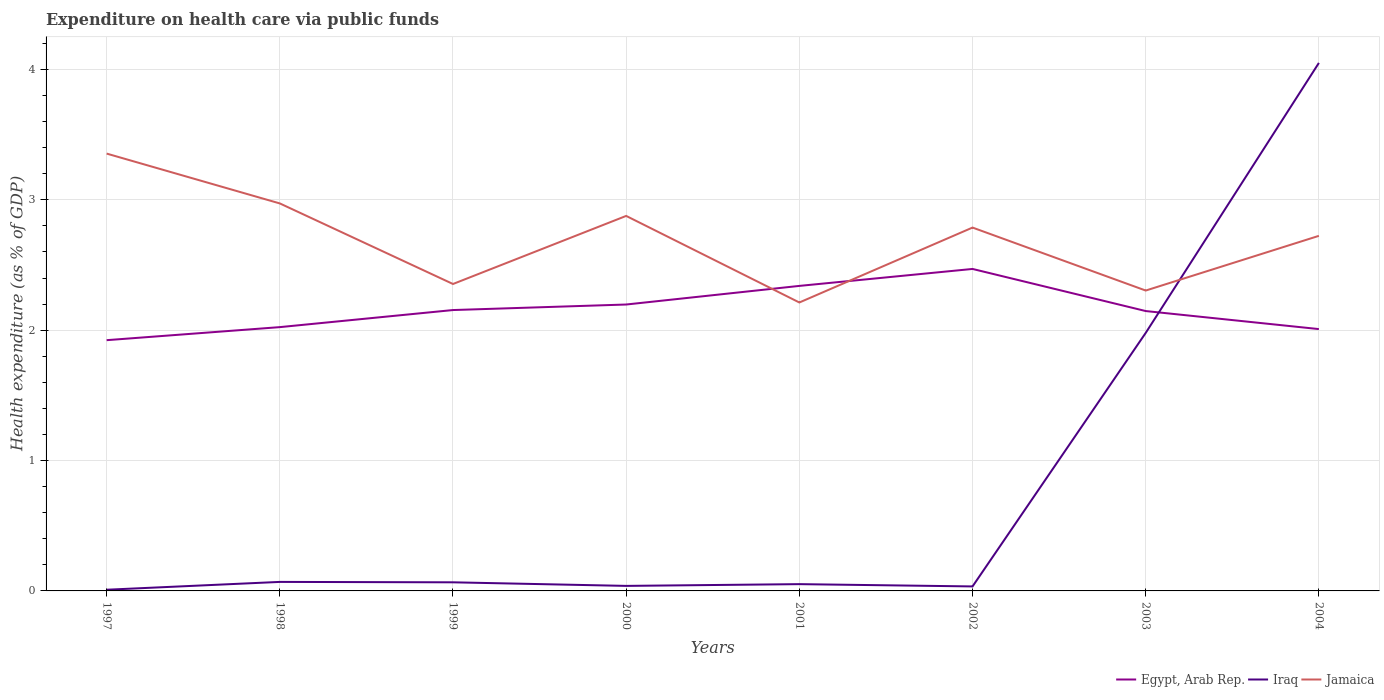How many different coloured lines are there?
Provide a short and direct response. 3. Is the number of lines equal to the number of legend labels?
Your response must be concise. Yes. Across all years, what is the maximum expenditure made on health care in Jamaica?
Your response must be concise. 2.21. In which year was the expenditure made on health care in Jamaica maximum?
Your answer should be compact. 2001. What is the total expenditure made on health care in Egypt, Arab Rep. in the graph?
Make the answer very short. 0.46. What is the difference between the highest and the second highest expenditure made on health care in Jamaica?
Provide a short and direct response. 1.14. What is the difference between the highest and the lowest expenditure made on health care in Iraq?
Offer a terse response. 2. How many years are there in the graph?
Provide a succinct answer. 8. What is the difference between two consecutive major ticks on the Y-axis?
Your answer should be compact. 1. Does the graph contain any zero values?
Make the answer very short. No. Does the graph contain grids?
Ensure brevity in your answer.  Yes. Where does the legend appear in the graph?
Provide a short and direct response. Bottom right. How are the legend labels stacked?
Your answer should be compact. Horizontal. What is the title of the graph?
Your answer should be compact. Expenditure on health care via public funds. What is the label or title of the Y-axis?
Offer a very short reply. Health expenditure (as % of GDP). What is the Health expenditure (as % of GDP) in Egypt, Arab Rep. in 1997?
Provide a succinct answer. 1.92. What is the Health expenditure (as % of GDP) in Iraq in 1997?
Make the answer very short. 0.01. What is the Health expenditure (as % of GDP) in Jamaica in 1997?
Provide a short and direct response. 3.35. What is the Health expenditure (as % of GDP) of Egypt, Arab Rep. in 1998?
Ensure brevity in your answer.  2.02. What is the Health expenditure (as % of GDP) in Iraq in 1998?
Offer a very short reply. 0.07. What is the Health expenditure (as % of GDP) in Jamaica in 1998?
Your response must be concise. 2.97. What is the Health expenditure (as % of GDP) in Egypt, Arab Rep. in 1999?
Provide a succinct answer. 2.15. What is the Health expenditure (as % of GDP) of Iraq in 1999?
Your answer should be compact. 0.07. What is the Health expenditure (as % of GDP) of Jamaica in 1999?
Offer a terse response. 2.35. What is the Health expenditure (as % of GDP) of Egypt, Arab Rep. in 2000?
Make the answer very short. 2.2. What is the Health expenditure (as % of GDP) of Iraq in 2000?
Offer a very short reply. 0.04. What is the Health expenditure (as % of GDP) of Jamaica in 2000?
Your answer should be very brief. 2.88. What is the Health expenditure (as % of GDP) of Egypt, Arab Rep. in 2001?
Offer a terse response. 2.34. What is the Health expenditure (as % of GDP) in Iraq in 2001?
Provide a short and direct response. 0.05. What is the Health expenditure (as % of GDP) in Jamaica in 2001?
Provide a succinct answer. 2.21. What is the Health expenditure (as % of GDP) of Egypt, Arab Rep. in 2002?
Keep it short and to the point. 2.47. What is the Health expenditure (as % of GDP) of Iraq in 2002?
Give a very brief answer. 0.03. What is the Health expenditure (as % of GDP) in Jamaica in 2002?
Ensure brevity in your answer.  2.79. What is the Health expenditure (as % of GDP) in Egypt, Arab Rep. in 2003?
Offer a terse response. 2.15. What is the Health expenditure (as % of GDP) in Iraq in 2003?
Ensure brevity in your answer.  1.98. What is the Health expenditure (as % of GDP) in Jamaica in 2003?
Offer a very short reply. 2.3. What is the Health expenditure (as % of GDP) of Egypt, Arab Rep. in 2004?
Keep it short and to the point. 2.01. What is the Health expenditure (as % of GDP) of Iraq in 2004?
Your answer should be compact. 4.05. What is the Health expenditure (as % of GDP) in Jamaica in 2004?
Your answer should be very brief. 2.72. Across all years, what is the maximum Health expenditure (as % of GDP) of Egypt, Arab Rep.?
Your response must be concise. 2.47. Across all years, what is the maximum Health expenditure (as % of GDP) of Iraq?
Offer a very short reply. 4.05. Across all years, what is the maximum Health expenditure (as % of GDP) in Jamaica?
Ensure brevity in your answer.  3.35. Across all years, what is the minimum Health expenditure (as % of GDP) in Egypt, Arab Rep.?
Provide a short and direct response. 1.92. Across all years, what is the minimum Health expenditure (as % of GDP) in Iraq?
Give a very brief answer. 0.01. Across all years, what is the minimum Health expenditure (as % of GDP) in Jamaica?
Your response must be concise. 2.21. What is the total Health expenditure (as % of GDP) in Egypt, Arab Rep. in the graph?
Make the answer very short. 17.26. What is the total Health expenditure (as % of GDP) of Iraq in the graph?
Make the answer very short. 6.3. What is the total Health expenditure (as % of GDP) of Jamaica in the graph?
Make the answer very short. 21.59. What is the difference between the Health expenditure (as % of GDP) in Egypt, Arab Rep. in 1997 and that in 1998?
Make the answer very short. -0.1. What is the difference between the Health expenditure (as % of GDP) in Iraq in 1997 and that in 1998?
Keep it short and to the point. -0.06. What is the difference between the Health expenditure (as % of GDP) in Jamaica in 1997 and that in 1998?
Offer a very short reply. 0.38. What is the difference between the Health expenditure (as % of GDP) in Egypt, Arab Rep. in 1997 and that in 1999?
Provide a succinct answer. -0.23. What is the difference between the Health expenditure (as % of GDP) in Iraq in 1997 and that in 1999?
Provide a short and direct response. -0.06. What is the difference between the Health expenditure (as % of GDP) in Egypt, Arab Rep. in 1997 and that in 2000?
Provide a succinct answer. -0.27. What is the difference between the Health expenditure (as % of GDP) of Iraq in 1997 and that in 2000?
Make the answer very short. -0.03. What is the difference between the Health expenditure (as % of GDP) in Jamaica in 1997 and that in 2000?
Provide a succinct answer. 0.48. What is the difference between the Health expenditure (as % of GDP) of Egypt, Arab Rep. in 1997 and that in 2001?
Ensure brevity in your answer.  -0.42. What is the difference between the Health expenditure (as % of GDP) of Iraq in 1997 and that in 2001?
Your answer should be very brief. -0.04. What is the difference between the Health expenditure (as % of GDP) of Jamaica in 1997 and that in 2001?
Offer a very short reply. 1.14. What is the difference between the Health expenditure (as % of GDP) in Egypt, Arab Rep. in 1997 and that in 2002?
Your answer should be very brief. -0.55. What is the difference between the Health expenditure (as % of GDP) in Iraq in 1997 and that in 2002?
Ensure brevity in your answer.  -0.03. What is the difference between the Health expenditure (as % of GDP) in Jamaica in 1997 and that in 2002?
Your answer should be compact. 0.57. What is the difference between the Health expenditure (as % of GDP) in Egypt, Arab Rep. in 1997 and that in 2003?
Your answer should be very brief. -0.22. What is the difference between the Health expenditure (as % of GDP) in Iraq in 1997 and that in 2003?
Give a very brief answer. -1.97. What is the difference between the Health expenditure (as % of GDP) of Jamaica in 1997 and that in 2003?
Provide a short and direct response. 1.05. What is the difference between the Health expenditure (as % of GDP) in Egypt, Arab Rep. in 1997 and that in 2004?
Make the answer very short. -0.09. What is the difference between the Health expenditure (as % of GDP) of Iraq in 1997 and that in 2004?
Provide a short and direct response. -4.04. What is the difference between the Health expenditure (as % of GDP) in Jamaica in 1997 and that in 2004?
Ensure brevity in your answer.  0.63. What is the difference between the Health expenditure (as % of GDP) of Egypt, Arab Rep. in 1998 and that in 1999?
Ensure brevity in your answer.  -0.13. What is the difference between the Health expenditure (as % of GDP) of Iraq in 1998 and that in 1999?
Your response must be concise. 0. What is the difference between the Health expenditure (as % of GDP) of Jamaica in 1998 and that in 1999?
Provide a succinct answer. 0.62. What is the difference between the Health expenditure (as % of GDP) of Egypt, Arab Rep. in 1998 and that in 2000?
Keep it short and to the point. -0.17. What is the difference between the Health expenditure (as % of GDP) of Iraq in 1998 and that in 2000?
Offer a terse response. 0.03. What is the difference between the Health expenditure (as % of GDP) of Jamaica in 1998 and that in 2000?
Offer a very short reply. 0.1. What is the difference between the Health expenditure (as % of GDP) in Egypt, Arab Rep. in 1998 and that in 2001?
Your answer should be compact. -0.32. What is the difference between the Health expenditure (as % of GDP) in Iraq in 1998 and that in 2001?
Ensure brevity in your answer.  0.02. What is the difference between the Health expenditure (as % of GDP) in Jamaica in 1998 and that in 2001?
Offer a terse response. 0.76. What is the difference between the Health expenditure (as % of GDP) in Egypt, Arab Rep. in 1998 and that in 2002?
Your response must be concise. -0.45. What is the difference between the Health expenditure (as % of GDP) of Iraq in 1998 and that in 2002?
Your answer should be very brief. 0.03. What is the difference between the Health expenditure (as % of GDP) of Jamaica in 1998 and that in 2002?
Provide a short and direct response. 0.19. What is the difference between the Health expenditure (as % of GDP) of Egypt, Arab Rep. in 1998 and that in 2003?
Offer a very short reply. -0.12. What is the difference between the Health expenditure (as % of GDP) in Iraq in 1998 and that in 2003?
Provide a succinct answer. -1.91. What is the difference between the Health expenditure (as % of GDP) of Jamaica in 1998 and that in 2003?
Provide a short and direct response. 0.67. What is the difference between the Health expenditure (as % of GDP) of Egypt, Arab Rep. in 1998 and that in 2004?
Provide a succinct answer. 0.02. What is the difference between the Health expenditure (as % of GDP) in Iraq in 1998 and that in 2004?
Make the answer very short. -3.98. What is the difference between the Health expenditure (as % of GDP) in Jamaica in 1998 and that in 2004?
Make the answer very short. 0.25. What is the difference between the Health expenditure (as % of GDP) of Egypt, Arab Rep. in 1999 and that in 2000?
Offer a terse response. -0.04. What is the difference between the Health expenditure (as % of GDP) of Iraq in 1999 and that in 2000?
Your response must be concise. 0.03. What is the difference between the Health expenditure (as % of GDP) of Jamaica in 1999 and that in 2000?
Keep it short and to the point. -0.52. What is the difference between the Health expenditure (as % of GDP) in Egypt, Arab Rep. in 1999 and that in 2001?
Provide a short and direct response. -0.19. What is the difference between the Health expenditure (as % of GDP) in Iraq in 1999 and that in 2001?
Your answer should be very brief. 0.01. What is the difference between the Health expenditure (as % of GDP) in Jamaica in 1999 and that in 2001?
Provide a short and direct response. 0.14. What is the difference between the Health expenditure (as % of GDP) in Egypt, Arab Rep. in 1999 and that in 2002?
Provide a short and direct response. -0.32. What is the difference between the Health expenditure (as % of GDP) in Iraq in 1999 and that in 2002?
Your response must be concise. 0.03. What is the difference between the Health expenditure (as % of GDP) of Jamaica in 1999 and that in 2002?
Offer a very short reply. -0.43. What is the difference between the Health expenditure (as % of GDP) of Egypt, Arab Rep. in 1999 and that in 2003?
Ensure brevity in your answer.  0.01. What is the difference between the Health expenditure (as % of GDP) in Iraq in 1999 and that in 2003?
Provide a succinct answer. -1.91. What is the difference between the Health expenditure (as % of GDP) of Jamaica in 1999 and that in 2003?
Make the answer very short. 0.05. What is the difference between the Health expenditure (as % of GDP) of Egypt, Arab Rep. in 1999 and that in 2004?
Your response must be concise. 0.15. What is the difference between the Health expenditure (as % of GDP) of Iraq in 1999 and that in 2004?
Offer a very short reply. -3.98. What is the difference between the Health expenditure (as % of GDP) of Jamaica in 1999 and that in 2004?
Offer a very short reply. -0.37. What is the difference between the Health expenditure (as % of GDP) of Egypt, Arab Rep. in 2000 and that in 2001?
Your answer should be very brief. -0.14. What is the difference between the Health expenditure (as % of GDP) of Iraq in 2000 and that in 2001?
Your answer should be very brief. -0.01. What is the difference between the Health expenditure (as % of GDP) of Jamaica in 2000 and that in 2001?
Your answer should be very brief. 0.66. What is the difference between the Health expenditure (as % of GDP) in Egypt, Arab Rep. in 2000 and that in 2002?
Offer a very short reply. -0.27. What is the difference between the Health expenditure (as % of GDP) of Iraq in 2000 and that in 2002?
Provide a short and direct response. 0. What is the difference between the Health expenditure (as % of GDP) in Jamaica in 2000 and that in 2002?
Your answer should be very brief. 0.09. What is the difference between the Health expenditure (as % of GDP) in Egypt, Arab Rep. in 2000 and that in 2003?
Provide a succinct answer. 0.05. What is the difference between the Health expenditure (as % of GDP) of Iraq in 2000 and that in 2003?
Keep it short and to the point. -1.94. What is the difference between the Health expenditure (as % of GDP) in Jamaica in 2000 and that in 2003?
Make the answer very short. 0.57. What is the difference between the Health expenditure (as % of GDP) of Egypt, Arab Rep. in 2000 and that in 2004?
Your answer should be compact. 0.19. What is the difference between the Health expenditure (as % of GDP) of Iraq in 2000 and that in 2004?
Keep it short and to the point. -4.01. What is the difference between the Health expenditure (as % of GDP) in Jamaica in 2000 and that in 2004?
Provide a short and direct response. 0.15. What is the difference between the Health expenditure (as % of GDP) in Egypt, Arab Rep. in 2001 and that in 2002?
Keep it short and to the point. -0.13. What is the difference between the Health expenditure (as % of GDP) in Iraq in 2001 and that in 2002?
Your answer should be very brief. 0.02. What is the difference between the Health expenditure (as % of GDP) in Jamaica in 2001 and that in 2002?
Make the answer very short. -0.57. What is the difference between the Health expenditure (as % of GDP) in Egypt, Arab Rep. in 2001 and that in 2003?
Give a very brief answer. 0.19. What is the difference between the Health expenditure (as % of GDP) in Iraq in 2001 and that in 2003?
Provide a short and direct response. -1.93. What is the difference between the Health expenditure (as % of GDP) of Jamaica in 2001 and that in 2003?
Give a very brief answer. -0.09. What is the difference between the Health expenditure (as % of GDP) in Egypt, Arab Rep. in 2001 and that in 2004?
Your answer should be compact. 0.33. What is the difference between the Health expenditure (as % of GDP) in Iraq in 2001 and that in 2004?
Provide a short and direct response. -4. What is the difference between the Health expenditure (as % of GDP) in Jamaica in 2001 and that in 2004?
Offer a very short reply. -0.51. What is the difference between the Health expenditure (as % of GDP) in Egypt, Arab Rep. in 2002 and that in 2003?
Keep it short and to the point. 0.32. What is the difference between the Health expenditure (as % of GDP) in Iraq in 2002 and that in 2003?
Your answer should be compact. -1.94. What is the difference between the Health expenditure (as % of GDP) in Jamaica in 2002 and that in 2003?
Make the answer very short. 0.48. What is the difference between the Health expenditure (as % of GDP) in Egypt, Arab Rep. in 2002 and that in 2004?
Your response must be concise. 0.46. What is the difference between the Health expenditure (as % of GDP) in Iraq in 2002 and that in 2004?
Provide a short and direct response. -4.02. What is the difference between the Health expenditure (as % of GDP) in Jamaica in 2002 and that in 2004?
Your answer should be very brief. 0.06. What is the difference between the Health expenditure (as % of GDP) in Egypt, Arab Rep. in 2003 and that in 2004?
Ensure brevity in your answer.  0.14. What is the difference between the Health expenditure (as % of GDP) of Iraq in 2003 and that in 2004?
Provide a succinct answer. -2.07. What is the difference between the Health expenditure (as % of GDP) in Jamaica in 2003 and that in 2004?
Your answer should be very brief. -0.42. What is the difference between the Health expenditure (as % of GDP) of Egypt, Arab Rep. in 1997 and the Health expenditure (as % of GDP) of Iraq in 1998?
Your response must be concise. 1.85. What is the difference between the Health expenditure (as % of GDP) of Egypt, Arab Rep. in 1997 and the Health expenditure (as % of GDP) of Jamaica in 1998?
Offer a very short reply. -1.05. What is the difference between the Health expenditure (as % of GDP) in Iraq in 1997 and the Health expenditure (as % of GDP) in Jamaica in 1998?
Your answer should be very brief. -2.96. What is the difference between the Health expenditure (as % of GDP) in Egypt, Arab Rep. in 1997 and the Health expenditure (as % of GDP) in Iraq in 1999?
Your answer should be very brief. 1.86. What is the difference between the Health expenditure (as % of GDP) in Egypt, Arab Rep. in 1997 and the Health expenditure (as % of GDP) in Jamaica in 1999?
Keep it short and to the point. -0.43. What is the difference between the Health expenditure (as % of GDP) of Iraq in 1997 and the Health expenditure (as % of GDP) of Jamaica in 1999?
Keep it short and to the point. -2.35. What is the difference between the Health expenditure (as % of GDP) in Egypt, Arab Rep. in 1997 and the Health expenditure (as % of GDP) in Iraq in 2000?
Your answer should be compact. 1.89. What is the difference between the Health expenditure (as % of GDP) in Egypt, Arab Rep. in 1997 and the Health expenditure (as % of GDP) in Jamaica in 2000?
Your answer should be compact. -0.95. What is the difference between the Health expenditure (as % of GDP) in Iraq in 1997 and the Health expenditure (as % of GDP) in Jamaica in 2000?
Your answer should be very brief. -2.87. What is the difference between the Health expenditure (as % of GDP) in Egypt, Arab Rep. in 1997 and the Health expenditure (as % of GDP) in Iraq in 2001?
Offer a terse response. 1.87. What is the difference between the Health expenditure (as % of GDP) in Egypt, Arab Rep. in 1997 and the Health expenditure (as % of GDP) in Jamaica in 2001?
Your response must be concise. -0.29. What is the difference between the Health expenditure (as % of GDP) of Iraq in 1997 and the Health expenditure (as % of GDP) of Jamaica in 2001?
Your response must be concise. -2.2. What is the difference between the Health expenditure (as % of GDP) of Egypt, Arab Rep. in 1997 and the Health expenditure (as % of GDP) of Iraq in 2002?
Make the answer very short. 1.89. What is the difference between the Health expenditure (as % of GDP) of Egypt, Arab Rep. in 1997 and the Health expenditure (as % of GDP) of Jamaica in 2002?
Offer a very short reply. -0.86. What is the difference between the Health expenditure (as % of GDP) of Iraq in 1997 and the Health expenditure (as % of GDP) of Jamaica in 2002?
Offer a very short reply. -2.78. What is the difference between the Health expenditure (as % of GDP) of Egypt, Arab Rep. in 1997 and the Health expenditure (as % of GDP) of Iraq in 2003?
Ensure brevity in your answer.  -0.06. What is the difference between the Health expenditure (as % of GDP) in Egypt, Arab Rep. in 1997 and the Health expenditure (as % of GDP) in Jamaica in 2003?
Provide a succinct answer. -0.38. What is the difference between the Health expenditure (as % of GDP) in Iraq in 1997 and the Health expenditure (as % of GDP) in Jamaica in 2003?
Provide a succinct answer. -2.3. What is the difference between the Health expenditure (as % of GDP) of Egypt, Arab Rep. in 1997 and the Health expenditure (as % of GDP) of Iraq in 2004?
Make the answer very short. -2.13. What is the difference between the Health expenditure (as % of GDP) of Egypt, Arab Rep. in 1997 and the Health expenditure (as % of GDP) of Jamaica in 2004?
Keep it short and to the point. -0.8. What is the difference between the Health expenditure (as % of GDP) in Iraq in 1997 and the Health expenditure (as % of GDP) in Jamaica in 2004?
Give a very brief answer. -2.71. What is the difference between the Health expenditure (as % of GDP) of Egypt, Arab Rep. in 1998 and the Health expenditure (as % of GDP) of Iraq in 1999?
Offer a very short reply. 1.96. What is the difference between the Health expenditure (as % of GDP) of Egypt, Arab Rep. in 1998 and the Health expenditure (as % of GDP) of Jamaica in 1999?
Provide a succinct answer. -0.33. What is the difference between the Health expenditure (as % of GDP) of Iraq in 1998 and the Health expenditure (as % of GDP) of Jamaica in 1999?
Offer a very short reply. -2.29. What is the difference between the Health expenditure (as % of GDP) of Egypt, Arab Rep. in 1998 and the Health expenditure (as % of GDP) of Iraq in 2000?
Offer a very short reply. 1.99. What is the difference between the Health expenditure (as % of GDP) in Egypt, Arab Rep. in 1998 and the Health expenditure (as % of GDP) in Jamaica in 2000?
Give a very brief answer. -0.85. What is the difference between the Health expenditure (as % of GDP) of Iraq in 1998 and the Health expenditure (as % of GDP) of Jamaica in 2000?
Your response must be concise. -2.81. What is the difference between the Health expenditure (as % of GDP) of Egypt, Arab Rep. in 1998 and the Health expenditure (as % of GDP) of Iraq in 2001?
Keep it short and to the point. 1.97. What is the difference between the Health expenditure (as % of GDP) of Egypt, Arab Rep. in 1998 and the Health expenditure (as % of GDP) of Jamaica in 2001?
Offer a terse response. -0.19. What is the difference between the Health expenditure (as % of GDP) of Iraq in 1998 and the Health expenditure (as % of GDP) of Jamaica in 2001?
Keep it short and to the point. -2.14. What is the difference between the Health expenditure (as % of GDP) of Egypt, Arab Rep. in 1998 and the Health expenditure (as % of GDP) of Iraq in 2002?
Provide a short and direct response. 1.99. What is the difference between the Health expenditure (as % of GDP) of Egypt, Arab Rep. in 1998 and the Health expenditure (as % of GDP) of Jamaica in 2002?
Offer a terse response. -0.76. What is the difference between the Health expenditure (as % of GDP) of Iraq in 1998 and the Health expenditure (as % of GDP) of Jamaica in 2002?
Your answer should be compact. -2.72. What is the difference between the Health expenditure (as % of GDP) of Egypt, Arab Rep. in 1998 and the Health expenditure (as % of GDP) of Iraq in 2003?
Your response must be concise. 0.04. What is the difference between the Health expenditure (as % of GDP) of Egypt, Arab Rep. in 1998 and the Health expenditure (as % of GDP) of Jamaica in 2003?
Offer a very short reply. -0.28. What is the difference between the Health expenditure (as % of GDP) of Iraq in 1998 and the Health expenditure (as % of GDP) of Jamaica in 2003?
Your response must be concise. -2.24. What is the difference between the Health expenditure (as % of GDP) in Egypt, Arab Rep. in 1998 and the Health expenditure (as % of GDP) in Iraq in 2004?
Offer a very short reply. -2.03. What is the difference between the Health expenditure (as % of GDP) of Egypt, Arab Rep. in 1998 and the Health expenditure (as % of GDP) of Jamaica in 2004?
Your response must be concise. -0.7. What is the difference between the Health expenditure (as % of GDP) in Iraq in 1998 and the Health expenditure (as % of GDP) in Jamaica in 2004?
Your answer should be very brief. -2.65. What is the difference between the Health expenditure (as % of GDP) of Egypt, Arab Rep. in 1999 and the Health expenditure (as % of GDP) of Iraq in 2000?
Offer a very short reply. 2.12. What is the difference between the Health expenditure (as % of GDP) of Egypt, Arab Rep. in 1999 and the Health expenditure (as % of GDP) of Jamaica in 2000?
Offer a very short reply. -0.72. What is the difference between the Health expenditure (as % of GDP) of Iraq in 1999 and the Health expenditure (as % of GDP) of Jamaica in 2000?
Your answer should be compact. -2.81. What is the difference between the Health expenditure (as % of GDP) in Egypt, Arab Rep. in 1999 and the Health expenditure (as % of GDP) in Iraq in 2001?
Make the answer very short. 2.1. What is the difference between the Health expenditure (as % of GDP) of Egypt, Arab Rep. in 1999 and the Health expenditure (as % of GDP) of Jamaica in 2001?
Your answer should be compact. -0.06. What is the difference between the Health expenditure (as % of GDP) of Iraq in 1999 and the Health expenditure (as % of GDP) of Jamaica in 2001?
Your answer should be compact. -2.15. What is the difference between the Health expenditure (as % of GDP) of Egypt, Arab Rep. in 1999 and the Health expenditure (as % of GDP) of Iraq in 2002?
Your answer should be very brief. 2.12. What is the difference between the Health expenditure (as % of GDP) of Egypt, Arab Rep. in 1999 and the Health expenditure (as % of GDP) of Jamaica in 2002?
Provide a short and direct response. -0.63. What is the difference between the Health expenditure (as % of GDP) of Iraq in 1999 and the Health expenditure (as % of GDP) of Jamaica in 2002?
Give a very brief answer. -2.72. What is the difference between the Health expenditure (as % of GDP) in Egypt, Arab Rep. in 1999 and the Health expenditure (as % of GDP) in Iraq in 2003?
Offer a terse response. 0.18. What is the difference between the Health expenditure (as % of GDP) in Egypt, Arab Rep. in 1999 and the Health expenditure (as % of GDP) in Jamaica in 2003?
Offer a very short reply. -0.15. What is the difference between the Health expenditure (as % of GDP) in Iraq in 1999 and the Health expenditure (as % of GDP) in Jamaica in 2003?
Offer a terse response. -2.24. What is the difference between the Health expenditure (as % of GDP) in Egypt, Arab Rep. in 1999 and the Health expenditure (as % of GDP) in Iraq in 2004?
Make the answer very short. -1.9. What is the difference between the Health expenditure (as % of GDP) in Egypt, Arab Rep. in 1999 and the Health expenditure (as % of GDP) in Jamaica in 2004?
Your response must be concise. -0.57. What is the difference between the Health expenditure (as % of GDP) of Iraq in 1999 and the Health expenditure (as % of GDP) of Jamaica in 2004?
Offer a very short reply. -2.66. What is the difference between the Health expenditure (as % of GDP) of Egypt, Arab Rep. in 2000 and the Health expenditure (as % of GDP) of Iraq in 2001?
Your answer should be compact. 2.15. What is the difference between the Health expenditure (as % of GDP) in Egypt, Arab Rep. in 2000 and the Health expenditure (as % of GDP) in Jamaica in 2001?
Your answer should be compact. -0.02. What is the difference between the Health expenditure (as % of GDP) in Iraq in 2000 and the Health expenditure (as % of GDP) in Jamaica in 2001?
Offer a terse response. -2.17. What is the difference between the Health expenditure (as % of GDP) in Egypt, Arab Rep. in 2000 and the Health expenditure (as % of GDP) in Iraq in 2002?
Your response must be concise. 2.16. What is the difference between the Health expenditure (as % of GDP) in Egypt, Arab Rep. in 2000 and the Health expenditure (as % of GDP) in Jamaica in 2002?
Give a very brief answer. -0.59. What is the difference between the Health expenditure (as % of GDP) of Iraq in 2000 and the Health expenditure (as % of GDP) of Jamaica in 2002?
Make the answer very short. -2.75. What is the difference between the Health expenditure (as % of GDP) of Egypt, Arab Rep. in 2000 and the Health expenditure (as % of GDP) of Iraq in 2003?
Provide a short and direct response. 0.22. What is the difference between the Health expenditure (as % of GDP) of Egypt, Arab Rep. in 2000 and the Health expenditure (as % of GDP) of Jamaica in 2003?
Make the answer very short. -0.11. What is the difference between the Health expenditure (as % of GDP) of Iraq in 2000 and the Health expenditure (as % of GDP) of Jamaica in 2003?
Keep it short and to the point. -2.27. What is the difference between the Health expenditure (as % of GDP) in Egypt, Arab Rep. in 2000 and the Health expenditure (as % of GDP) in Iraq in 2004?
Make the answer very short. -1.85. What is the difference between the Health expenditure (as % of GDP) of Egypt, Arab Rep. in 2000 and the Health expenditure (as % of GDP) of Jamaica in 2004?
Provide a succinct answer. -0.53. What is the difference between the Health expenditure (as % of GDP) of Iraq in 2000 and the Health expenditure (as % of GDP) of Jamaica in 2004?
Provide a succinct answer. -2.69. What is the difference between the Health expenditure (as % of GDP) in Egypt, Arab Rep. in 2001 and the Health expenditure (as % of GDP) in Iraq in 2002?
Offer a very short reply. 2.31. What is the difference between the Health expenditure (as % of GDP) in Egypt, Arab Rep. in 2001 and the Health expenditure (as % of GDP) in Jamaica in 2002?
Provide a succinct answer. -0.45. What is the difference between the Health expenditure (as % of GDP) of Iraq in 2001 and the Health expenditure (as % of GDP) of Jamaica in 2002?
Your answer should be compact. -2.74. What is the difference between the Health expenditure (as % of GDP) in Egypt, Arab Rep. in 2001 and the Health expenditure (as % of GDP) in Iraq in 2003?
Your answer should be compact. 0.36. What is the difference between the Health expenditure (as % of GDP) in Egypt, Arab Rep. in 2001 and the Health expenditure (as % of GDP) in Jamaica in 2003?
Your answer should be very brief. 0.04. What is the difference between the Health expenditure (as % of GDP) in Iraq in 2001 and the Health expenditure (as % of GDP) in Jamaica in 2003?
Make the answer very short. -2.25. What is the difference between the Health expenditure (as % of GDP) of Egypt, Arab Rep. in 2001 and the Health expenditure (as % of GDP) of Iraq in 2004?
Keep it short and to the point. -1.71. What is the difference between the Health expenditure (as % of GDP) of Egypt, Arab Rep. in 2001 and the Health expenditure (as % of GDP) of Jamaica in 2004?
Offer a terse response. -0.38. What is the difference between the Health expenditure (as % of GDP) of Iraq in 2001 and the Health expenditure (as % of GDP) of Jamaica in 2004?
Your response must be concise. -2.67. What is the difference between the Health expenditure (as % of GDP) in Egypt, Arab Rep. in 2002 and the Health expenditure (as % of GDP) in Iraq in 2003?
Provide a succinct answer. 0.49. What is the difference between the Health expenditure (as % of GDP) in Egypt, Arab Rep. in 2002 and the Health expenditure (as % of GDP) in Jamaica in 2003?
Provide a succinct answer. 0.17. What is the difference between the Health expenditure (as % of GDP) of Iraq in 2002 and the Health expenditure (as % of GDP) of Jamaica in 2003?
Ensure brevity in your answer.  -2.27. What is the difference between the Health expenditure (as % of GDP) of Egypt, Arab Rep. in 2002 and the Health expenditure (as % of GDP) of Iraq in 2004?
Offer a terse response. -1.58. What is the difference between the Health expenditure (as % of GDP) in Egypt, Arab Rep. in 2002 and the Health expenditure (as % of GDP) in Jamaica in 2004?
Ensure brevity in your answer.  -0.25. What is the difference between the Health expenditure (as % of GDP) of Iraq in 2002 and the Health expenditure (as % of GDP) of Jamaica in 2004?
Provide a short and direct response. -2.69. What is the difference between the Health expenditure (as % of GDP) of Egypt, Arab Rep. in 2003 and the Health expenditure (as % of GDP) of Iraq in 2004?
Give a very brief answer. -1.9. What is the difference between the Health expenditure (as % of GDP) of Egypt, Arab Rep. in 2003 and the Health expenditure (as % of GDP) of Jamaica in 2004?
Offer a terse response. -0.58. What is the difference between the Health expenditure (as % of GDP) in Iraq in 2003 and the Health expenditure (as % of GDP) in Jamaica in 2004?
Make the answer very short. -0.74. What is the average Health expenditure (as % of GDP) of Egypt, Arab Rep. per year?
Provide a succinct answer. 2.16. What is the average Health expenditure (as % of GDP) of Iraq per year?
Ensure brevity in your answer.  0.79. What is the average Health expenditure (as % of GDP) in Jamaica per year?
Make the answer very short. 2.7. In the year 1997, what is the difference between the Health expenditure (as % of GDP) in Egypt, Arab Rep. and Health expenditure (as % of GDP) in Iraq?
Provide a short and direct response. 1.91. In the year 1997, what is the difference between the Health expenditure (as % of GDP) of Egypt, Arab Rep. and Health expenditure (as % of GDP) of Jamaica?
Ensure brevity in your answer.  -1.43. In the year 1997, what is the difference between the Health expenditure (as % of GDP) of Iraq and Health expenditure (as % of GDP) of Jamaica?
Offer a very short reply. -3.35. In the year 1998, what is the difference between the Health expenditure (as % of GDP) in Egypt, Arab Rep. and Health expenditure (as % of GDP) in Iraq?
Keep it short and to the point. 1.95. In the year 1998, what is the difference between the Health expenditure (as % of GDP) of Egypt, Arab Rep. and Health expenditure (as % of GDP) of Jamaica?
Your answer should be compact. -0.95. In the year 1998, what is the difference between the Health expenditure (as % of GDP) of Iraq and Health expenditure (as % of GDP) of Jamaica?
Your answer should be compact. -2.9. In the year 1999, what is the difference between the Health expenditure (as % of GDP) in Egypt, Arab Rep. and Health expenditure (as % of GDP) in Iraq?
Ensure brevity in your answer.  2.09. In the year 1999, what is the difference between the Health expenditure (as % of GDP) in Egypt, Arab Rep. and Health expenditure (as % of GDP) in Jamaica?
Your answer should be compact. -0.2. In the year 1999, what is the difference between the Health expenditure (as % of GDP) of Iraq and Health expenditure (as % of GDP) of Jamaica?
Your answer should be compact. -2.29. In the year 2000, what is the difference between the Health expenditure (as % of GDP) in Egypt, Arab Rep. and Health expenditure (as % of GDP) in Iraq?
Offer a very short reply. 2.16. In the year 2000, what is the difference between the Health expenditure (as % of GDP) in Egypt, Arab Rep. and Health expenditure (as % of GDP) in Jamaica?
Your answer should be compact. -0.68. In the year 2000, what is the difference between the Health expenditure (as % of GDP) in Iraq and Health expenditure (as % of GDP) in Jamaica?
Keep it short and to the point. -2.84. In the year 2001, what is the difference between the Health expenditure (as % of GDP) in Egypt, Arab Rep. and Health expenditure (as % of GDP) in Iraq?
Ensure brevity in your answer.  2.29. In the year 2001, what is the difference between the Health expenditure (as % of GDP) in Egypt, Arab Rep. and Health expenditure (as % of GDP) in Jamaica?
Provide a short and direct response. 0.13. In the year 2001, what is the difference between the Health expenditure (as % of GDP) in Iraq and Health expenditure (as % of GDP) in Jamaica?
Provide a short and direct response. -2.16. In the year 2002, what is the difference between the Health expenditure (as % of GDP) of Egypt, Arab Rep. and Health expenditure (as % of GDP) of Iraq?
Keep it short and to the point. 2.44. In the year 2002, what is the difference between the Health expenditure (as % of GDP) of Egypt, Arab Rep. and Health expenditure (as % of GDP) of Jamaica?
Provide a succinct answer. -0.32. In the year 2002, what is the difference between the Health expenditure (as % of GDP) of Iraq and Health expenditure (as % of GDP) of Jamaica?
Offer a terse response. -2.75. In the year 2003, what is the difference between the Health expenditure (as % of GDP) in Egypt, Arab Rep. and Health expenditure (as % of GDP) in Iraq?
Your answer should be very brief. 0.17. In the year 2003, what is the difference between the Health expenditure (as % of GDP) of Egypt, Arab Rep. and Health expenditure (as % of GDP) of Jamaica?
Provide a succinct answer. -0.16. In the year 2003, what is the difference between the Health expenditure (as % of GDP) in Iraq and Health expenditure (as % of GDP) in Jamaica?
Keep it short and to the point. -0.32. In the year 2004, what is the difference between the Health expenditure (as % of GDP) in Egypt, Arab Rep. and Health expenditure (as % of GDP) in Iraq?
Ensure brevity in your answer.  -2.04. In the year 2004, what is the difference between the Health expenditure (as % of GDP) of Egypt, Arab Rep. and Health expenditure (as % of GDP) of Jamaica?
Offer a very short reply. -0.72. In the year 2004, what is the difference between the Health expenditure (as % of GDP) of Iraq and Health expenditure (as % of GDP) of Jamaica?
Give a very brief answer. 1.33. What is the ratio of the Health expenditure (as % of GDP) of Egypt, Arab Rep. in 1997 to that in 1998?
Your response must be concise. 0.95. What is the ratio of the Health expenditure (as % of GDP) in Iraq in 1997 to that in 1998?
Your response must be concise. 0.13. What is the ratio of the Health expenditure (as % of GDP) of Jamaica in 1997 to that in 1998?
Offer a very short reply. 1.13. What is the ratio of the Health expenditure (as % of GDP) of Egypt, Arab Rep. in 1997 to that in 1999?
Your answer should be very brief. 0.89. What is the ratio of the Health expenditure (as % of GDP) in Iraq in 1997 to that in 1999?
Ensure brevity in your answer.  0.14. What is the ratio of the Health expenditure (as % of GDP) of Jamaica in 1997 to that in 1999?
Ensure brevity in your answer.  1.42. What is the ratio of the Health expenditure (as % of GDP) in Egypt, Arab Rep. in 1997 to that in 2000?
Your response must be concise. 0.88. What is the ratio of the Health expenditure (as % of GDP) in Iraq in 1997 to that in 2000?
Your answer should be very brief. 0.23. What is the ratio of the Health expenditure (as % of GDP) in Jamaica in 1997 to that in 2000?
Your answer should be compact. 1.17. What is the ratio of the Health expenditure (as % of GDP) of Egypt, Arab Rep. in 1997 to that in 2001?
Offer a very short reply. 0.82. What is the ratio of the Health expenditure (as % of GDP) of Iraq in 1997 to that in 2001?
Make the answer very short. 0.17. What is the ratio of the Health expenditure (as % of GDP) of Jamaica in 1997 to that in 2001?
Your answer should be very brief. 1.52. What is the ratio of the Health expenditure (as % of GDP) of Egypt, Arab Rep. in 1997 to that in 2002?
Your response must be concise. 0.78. What is the ratio of the Health expenditure (as % of GDP) in Iraq in 1997 to that in 2002?
Offer a very short reply. 0.26. What is the ratio of the Health expenditure (as % of GDP) in Jamaica in 1997 to that in 2002?
Offer a very short reply. 1.2. What is the ratio of the Health expenditure (as % of GDP) of Egypt, Arab Rep. in 1997 to that in 2003?
Give a very brief answer. 0.9. What is the ratio of the Health expenditure (as % of GDP) in Iraq in 1997 to that in 2003?
Make the answer very short. 0. What is the ratio of the Health expenditure (as % of GDP) of Jamaica in 1997 to that in 2003?
Offer a very short reply. 1.46. What is the ratio of the Health expenditure (as % of GDP) of Egypt, Arab Rep. in 1997 to that in 2004?
Make the answer very short. 0.96. What is the ratio of the Health expenditure (as % of GDP) in Iraq in 1997 to that in 2004?
Ensure brevity in your answer.  0. What is the ratio of the Health expenditure (as % of GDP) in Jamaica in 1997 to that in 2004?
Provide a succinct answer. 1.23. What is the ratio of the Health expenditure (as % of GDP) in Egypt, Arab Rep. in 1998 to that in 1999?
Provide a succinct answer. 0.94. What is the ratio of the Health expenditure (as % of GDP) of Iraq in 1998 to that in 1999?
Your answer should be compact. 1.05. What is the ratio of the Health expenditure (as % of GDP) of Jamaica in 1998 to that in 1999?
Offer a terse response. 1.26. What is the ratio of the Health expenditure (as % of GDP) in Egypt, Arab Rep. in 1998 to that in 2000?
Your response must be concise. 0.92. What is the ratio of the Health expenditure (as % of GDP) of Iraq in 1998 to that in 2000?
Your answer should be compact. 1.79. What is the ratio of the Health expenditure (as % of GDP) in Jamaica in 1998 to that in 2000?
Provide a short and direct response. 1.03. What is the ratio of the Health expenditure (as % of GDP) in Egypt, Arab Rep. in 1998 to that in 2001?
Provide a short and direct response. 0.86. What is the ratio of the Health expenditure (as % of GDP) in Iraq in 1998 to that in 2001?
Provide a succinct answer. 1.33. What is the ratio of the Health expenditure (as % of GDP) of Jamaica in 1998 to that in 2001?
Ensure brevity in your answer.  1.34. What is the ratio of the Health expenditure (as % of GDP) in Egypt, Arab Rep. in 1998 to that in 2002?
Make the answer very short. 0.82. What is the ratio of the Health expenditure (as % of GDP) in Iraq in 1998 to that in 2002?
Make the answer very short. 2.01. What is the ratio of the Health expenditure (as % of GDP) in Jamaica in 1998 to that in 2002?
Your answer should be compact. 1.07. What is the ratio of the Health expenditure (as % of GDP) of Egypt, Arab Rep. in 1998 to that in 2003?
Provide a short and direct response. 0.94. What is the ratio of the Health expenditure (as % of GDP) in Iraq in 1998 to that in 2003?
Ensure brevity in your answer.  0.03. What is the ratio of the Health expenditure (as % of GDP) in Jamaica in 1998 to that in 2003?
Offer a terse response. 1.29. What is the ratio of the Health expenditure (as % of GDP) of Egypt, Arab Rep. in 1998 to that in 2004?
Your answer should be compact. 1.01. What is the ratio of the Health expenditure (as % of GDP) in Iraq in 1998 to that in 2004?
Ensure brevity in your answer.  0.02. What is the ratio of the Health expenditure (as % of GDP) in Jamaica in 1998 to that in 2004?
Make the answer very short. 1.09. What is the ratio of the Health expenditure (as % of GDP) of Egypt, Arab Rep. in 1999 to that in 2000?
Your response must be concise. 0.98. What is the ratio of the Health expenditure (as % of GDP) of Iraq in 1999 to that in 2000?
Offer a very short reply. 1.71. What is the ratio of the Health expenditure (as % of GDP) in Jamaica in 1999 to that in 2000?
Provide a short and direct response. 0.82. What is the ratio of the Health expenditure (as % of GDP) of Egypt, Arab Rep. in 1999 to that in 2001?
Keep it short and to the point. 0.92. What is the ratio of the Health expenditure (as % of GDP) of Iraq in 1999 to that in 2001?
Give a very brief answer. 1.27. What is the ratio of the Health expenditure (as % of GDP) in Jamaica in 1999 to that in 2001?
Offer a very short reply. 1.06. What is the ratio of the Health expenditure (as % of GDP) of Egypt, Arab Rep. in 1999 to that in 2002?
Give a very brief answer. 0.87. What is the ratio of the Health expenditure (as % of GDP) of Iraq in 1999 to that in 2002?
Provide a succinct answer. 1.92. What is the ratio of the Health expenditure (as % of GDP) of Jamaica in 1999 to that in 2002?
Your answer should be compact. 0.84. What is the ratio of the Health expenditure (as % of GDP) of Iraq in 1999 to that in 2003?
Offer a very short reply. 0.03. What is the ratio of the Health expenditure (as % of GDP) of Jamaica in 1999 to that in 2003?
Provide a short and direct response. 1.02. What is the ratio of the Health expenditure (as % of GDP) of Egypt, Arab Rep. in 1999 to that in 2004?
Offer a very short reply. 1.07. What is the ratio of the Health expenditure (as % of GDP) in Iraq in 1999 to that in 2004?
Your answer should be very brief. 0.02. What is the ratio of the Health expenditure (as % of GDP) in Jamaica in 1999 to that in 2004?
Provide a succinct answer. 0.86. What is the ratio of the Health expenditure (as % of GDP) of Egypt, Arab Rep. in 2000 to that in 2001?
Your response must be concise. 0.94. What is the ratio of the Health expenditure (as % of GDP) in Iraq in 2000 to that in 2001?
Ensure brevity in your answer.  0.74. What is the ratio of the Health expenditure (as % of GDP) in Jamaica in 2000 to that in 2001?
Provide a succinct answer. 1.3. What is the ratio of the Health expenditure (as % of GDP) in Egypt, Arab Rep. in 2000 to that in 2002?
Provide a succinct answer. 0.89. What is the ratio of the Health expenditure (as % of GDP) of Iraq in 2000 to that in 2002?
Your answer should be very brief. 1.12. What is the ratio of the Health expenditure (as % of GDP) in Jamaica in 2000 to that in 2002?
Keep it short and to the point. 1.03. What is the ratio of the Health expenditure (as % of GDP) of Egypt, Arab Rep. in 2000 to that in 2003?
Offer a very short reply. 1.02. What is the ratio of the Health expenditure (as % of GDP) of Iraq in 2000 to that in 2003?
Provide a short and direct response. 0.02. What is the ratio of the Health expenditure (as % of GDP) of Jamaica in 2000 to that in 2003?
Make the answer very short. 1.25. What is the ratio of the Health expenditure (as % of GDP) in Egypt, Arab Rep. in 2000 to that in 2004?
Ensure brevity in your answer.  1.09. What is the ratio of the Health expenditure (as % of GDP) in Iraq in 2000 to that in 2004?
Provide a short and direct response. 0.01. What is the ratio of the Health expenditure (as % of GDP) of Jamaica in 2000 to that in 2004?
Provide a succinct answer. 1.06. What is the ratio of the Health expenditure (as % of GDP) in Egypt, Arab Rep. in 2001 to that in 2002?
Provide a succinct answer. 0.95. What is the ratio of the Health expenditure (as % of GDP) of Iraq in 2001 to that in 2002?
Keep it short and to the point. 1.51. What is the ratio of the Health expenditure (as % of GDP) in Jamaica in 2001 to that in 2002?
Provide a succinct answer. 0.79. What is the ratio of the Health expenditure (as % of GDP) of Egypt, Arab Rep. in 2001 to that in 2003?
Offer a very short reply. 1.09. What is the ratio of the Health expenditure (as % of GDP) of Iraq in 2001 to that in 2003?
Ensure brevity in your answer.  0.03. What is the ratio of the Health expenditure (as % of GDP) of Jamaica in 2001 to that in 2003?
Your response must be concise. 0.96. What is the ratio of the Health expenditure (as % of GDP) of Egypt, Arab Rep. in 2001 to that in 2004?
Your answer should be very brief. 1.16. What is the ratio of the Health expenditure (as % of GDP) of Iraq in 2001 to that in 2004?
Provide a short and direct response. 0.01. What is the ratio of the Health expenditure (as % of GDP) of Jamaica in 2001 to that in 2004?
Offer a terse response. 0.81. What is the ratio of the Health expenditure (as % of GDP) of Egypt, Arab Rep. in 2002 to that in 2003?
Give a very brief answer. 1.15. What is the ratio of the Health expenditure (as % of GDP) in Iraq in 2002 to that in 2003?
Ensure brevity in your answer.  0.02. What is the ratio of the Health expenditure (as % of GDP) of Jamaica in 2002 to that in 2003?
Provide a succinct answer. 1.21. What is the ratio of the Health expenditure (as % of GDP) in Egypt, Arab Rep. in 2002 to that in 2004?
Give a very brief answer. 1.23. What is the ratio of the Health expenditure (as % of GDP) of Iraq in 2002 to that in 2004?
Make the answer very short. 0.01. What is the ratio of the Health expenditure (as % of GDP) in Jamaica in 2002 to that in 2004?
Give a very brief answer. 1.02. What is the ratio of the Health expenditure (as % of GDP) of Egypt, Arab Rep. in 2003 to that in 2004?
Make the answer very short. 1.07. What is the ratio of the Health expenditure (as % of GDP) of Iraq in 2003 to that in 2004?
Offer a very short reply. 0.49. What is the ratio of the Health expenditure (as % of GDP) in Jamaica in 2003 to that in 2004?
Your response must be concise. 0.85. What is the difference between the highest and the second highest Health expenditure (as % of GDP) in Egypt, Arab Rep.?
Give a very brief answer. 0.13. What is the difference between the highest and the second highest Health expenditure (as % of GDP) of Iraq?
Your answer should be very brief. 2.07. What is the difference between the highest and the second highest Health expenditure (as % of GDP) of Jamaica?
Make the answer very short. 0.38. What is the difference between the highest and the lowest Health expenditure (as % of GDP) of Egypt, Arab Rep.?
Ensure brevity in your answer.  0.55. What is the difference between the highest and the lowest Health expenditure (as % of GDP) of Iraq?
Make the answer very short. 4.04. What is the difference between the highest and the lowest Health expenditure (as % of GDP) in Jamaica?
Provide a succinct answer. 1.14. 